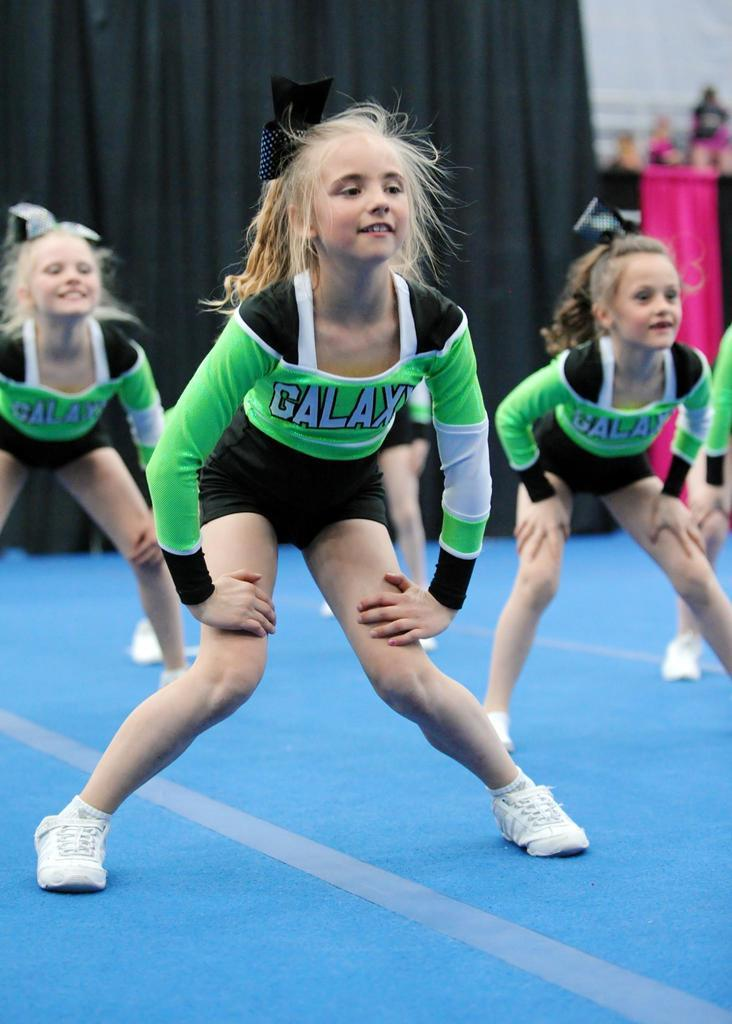<image>
Give a short and clear explanation of the subsequent image. Girls are wearing green shirts that have galax on the front. 